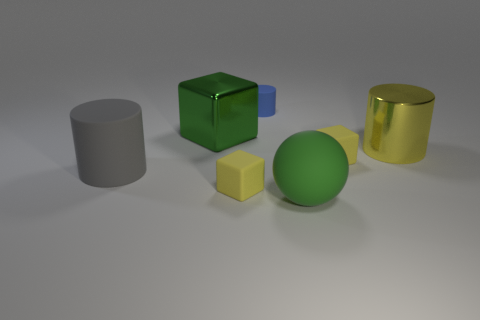There is a large matte ball to the right of the green block; is its color the same as the metallic block that is right of the large gray thing?
Your answer should be compact. Yes. What is the material of the ball that is the same size as the gray rubber thing?
Provide a succinct answer. Rubber. What shape is the yellow thing in front of the yellow block behind the yellow thing that is to the left of the small blue rubber cylinder?
Keep it short and to the point. Cube. There is a green metal thing that is the same size as the metallic cylinder; what shape is it?
Make the answer very short. Cube. There is a big metal thing that is on the left side of the small matte cube on the left side of the tiny blue thing; what number of big things are behind it?
Ensure brevity in your answer.  0. Is the number of large gray rubber objects in front of the big metallic cube greater than the number of large green spheres that are behind the green ball?
Give a very brief answer. Yes. How many other rubber things have the same shape as the big yellow thing?
Provide a succinct answer. 2. How many things are either large green things in front of the yellow cylinder or small rubber things that are left of the big sphere?
Provide a succinct answer. 3. The large cylinder that is to the right of the tiny matte block in front of the rubber cube that is behind the large rubber cylinder is made of what material?
Give a very brief answer. Metal. There is a large object that is behind the large yellow cylinder; does it have the same color as the big matte ball?
Your answer should be very brief. Yes. 